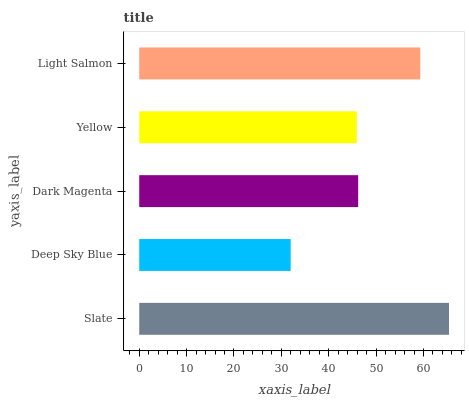Is Deep Sky Blue the minimum?
Answer yes or no. Yes. Is Slate the maximum?
Answer yes or no. Yes. Is Dark Magenta the minimum?
Answer yes or no. No. Is Dark Magenta the maximum?
Answer yes or no. No. Is Dark Magenta greater than Deep Sky Blue?
Answer yes or no. Yes. Is Deep Sky Blue less than Dark Magenta?
Answer yes or no. Yes. Is Deep Sky Blue greater than Dark Magenta?
Answer yes or no. No. Is Dark Magenta less than Deep Sky Blue?
Answer yes or no. No. Is Dark Magenta the high median?
Answer yes or no. Yes. Is Dark Magenta the low median?
Answer yes or no. Yes. Is Deep Sky Blue the high median?
Answer yes or no. No. Is Yellow the low median?
Answer yes or no. No. 